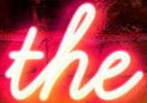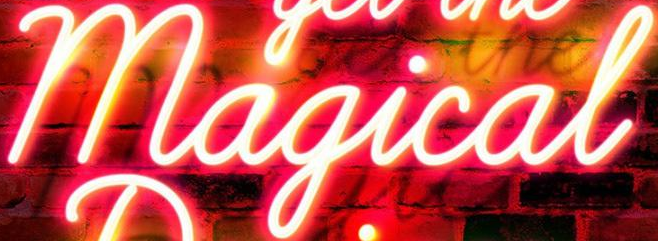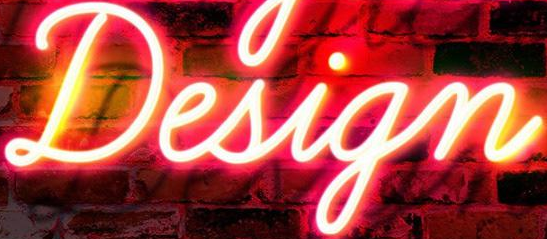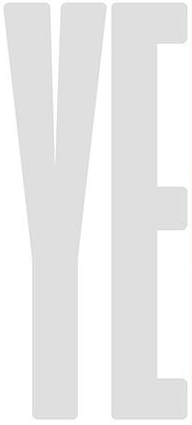What text appears in these images from left to right, separated by a semicolon? the; Magical; Design; YE 